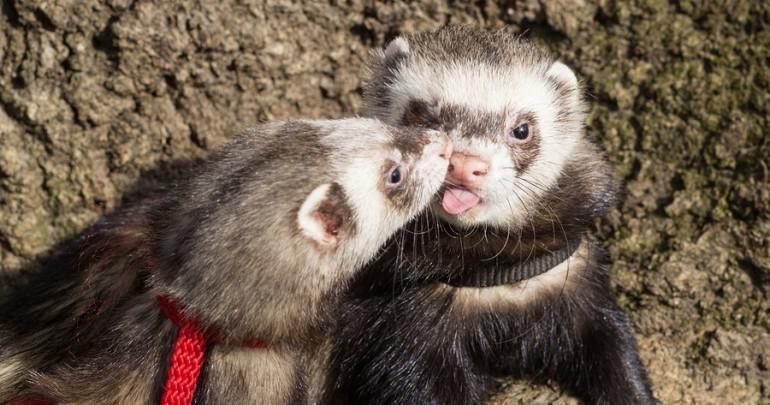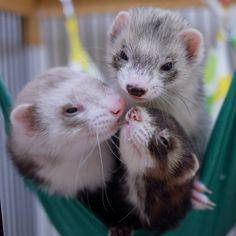The first image is the image on the left, the second image is the image on the right. For the images shown, is this caption "There are three ferrets in one of the images." true? Answer yes or no. Yes. The first image is the image on the left, the second image is the image on the right. Analyze the images presented: Is the assertion "There are at most 3 ferretts in the image pair." valid? Answer yes or no. No. 